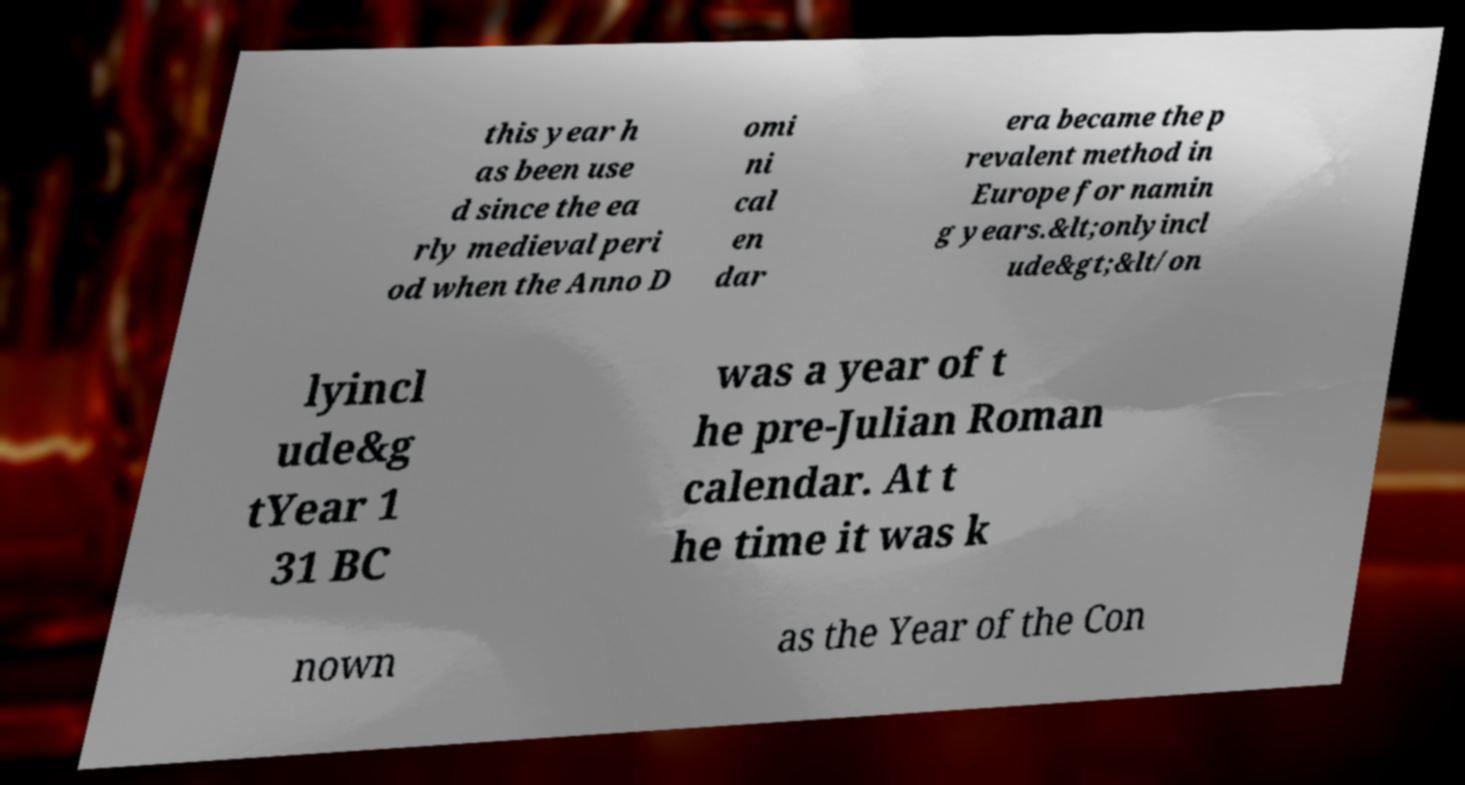For documentation purposes, I need the text within this image transcribed. Could you provide that? this year h as been use d since the ea rly medieval peri od when the Anno D omi ni cal en dar era became the p revalent method in Europe for namin g years.&lt;onlyincl ude&gt;&lt/on lyincl ude&g tYear 1 31 BC was a year of t he pre-Julian Roman calendar. At t he time it was k nown as the Year of the Con 